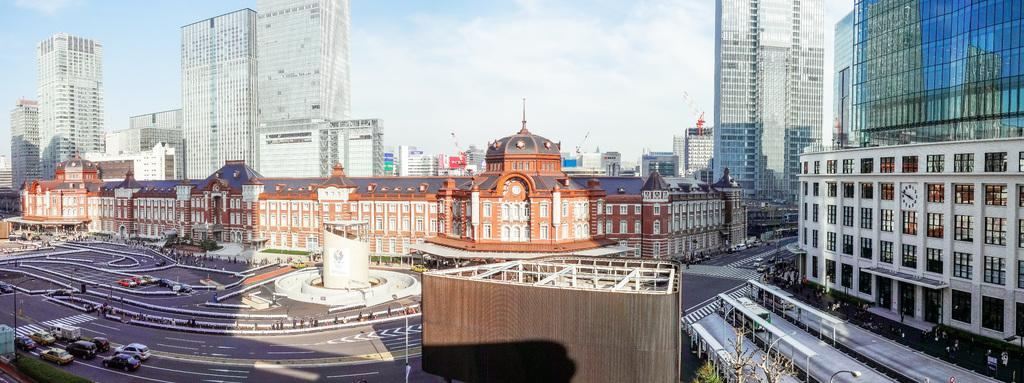What type of structures can be seen in the image? There are buildings in the image. What else can be seen in the image besides buildings? There are poles, lights, trees, vehicles on the road, and other objects in the image. What is the purpose of the poles in the image? The poles may be used for supporting lights or other infrastructure. What is visible in the background of the image? The sky is visible in the background of the image. Can you see any cracks in the buildings in the image? There is no mention of cracks in the buildings in the provided facts, so we cannot determine if any cracks are present in the image. Is there any indication of a war happening in the image? There is no indication of a war or any conflict in the image, as it primarily features buildings, poles, lights, trees, vehicles, and the sky. 